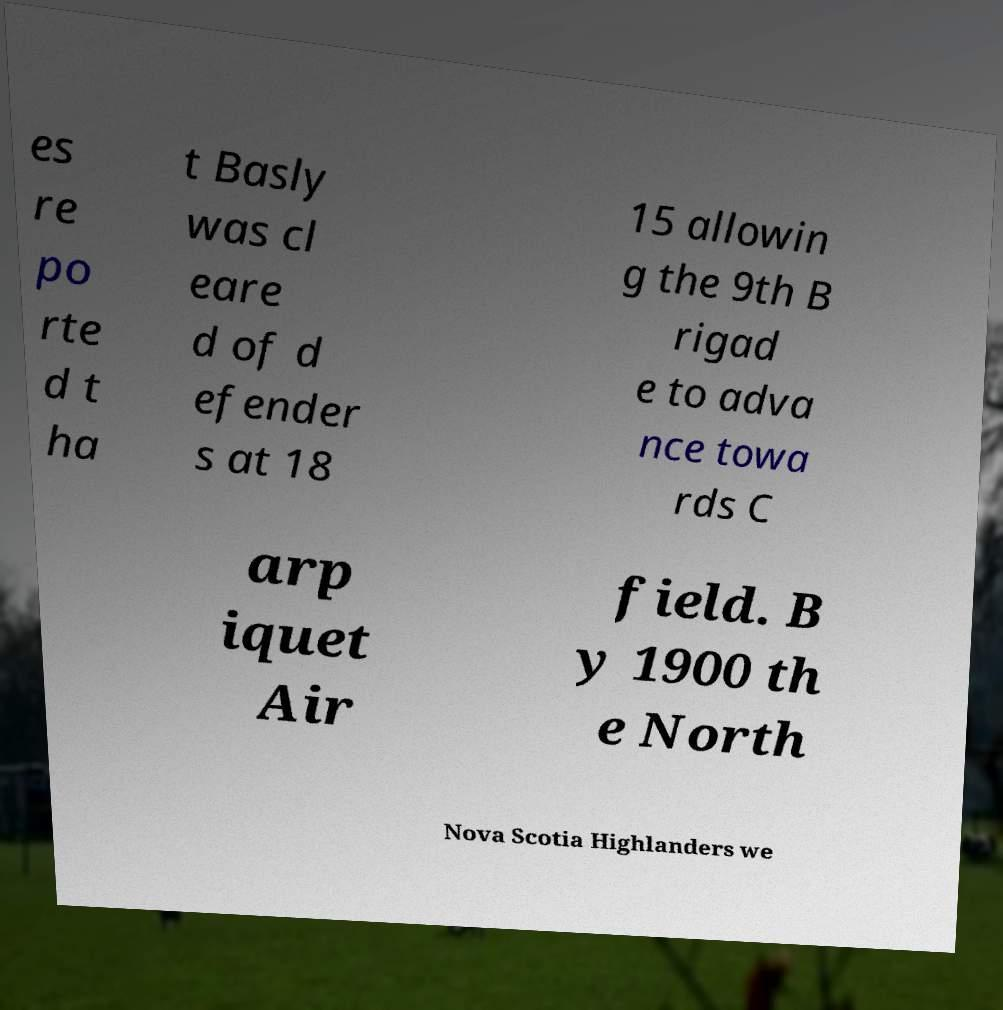What messages or text are displayed in this image? I need them in a readable, typed format. es re po rte d t ha t Basly was cl eare d of d efender s at 18 15 allowin g the 9th B rigad e to adva nce towa rds C arp iquet Air field. B y 1900 th e North Nova Scotia Highlanders we 